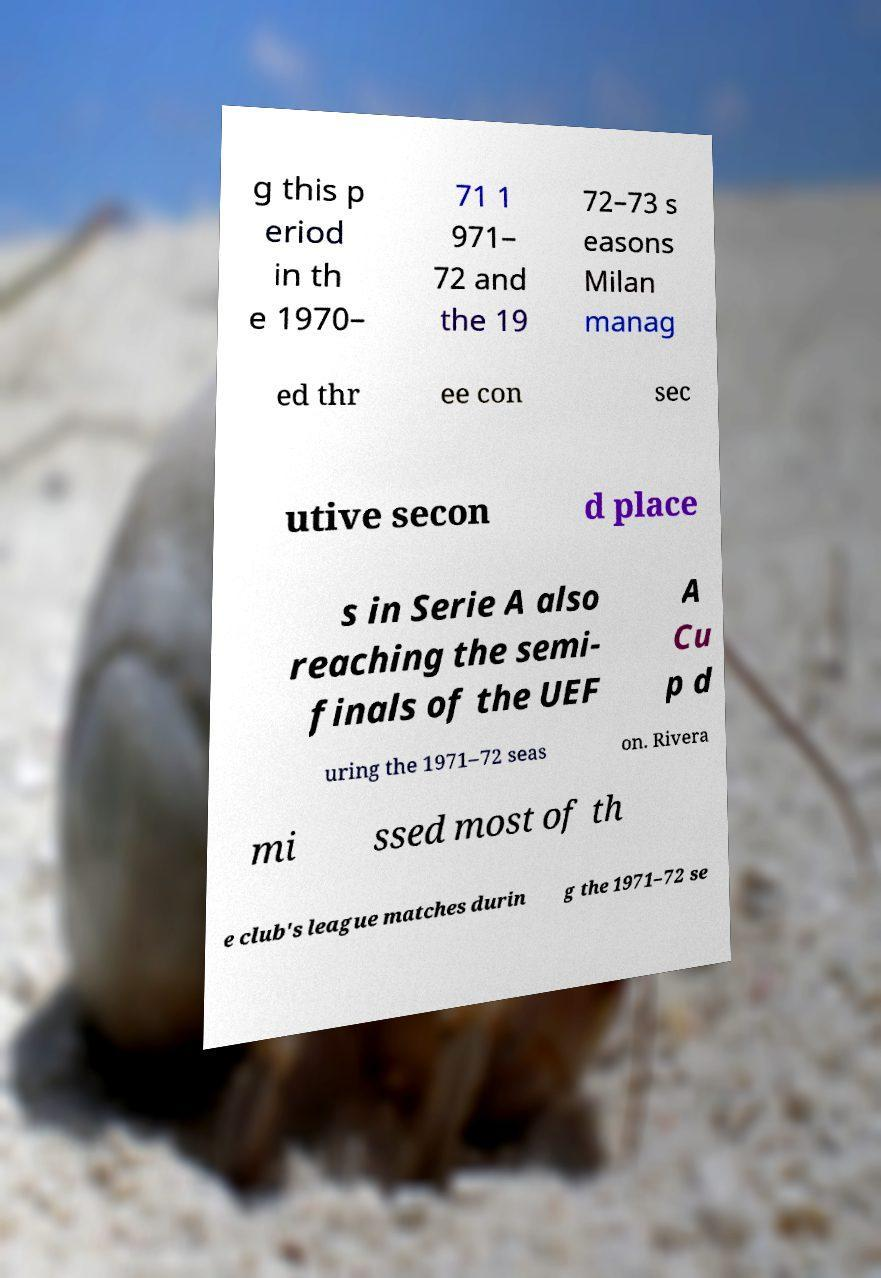Please read and relay the text visible in this image. What does it say? g this p eriod in th e 1970– 71 1 971– 72 and the 19 72–73 s easons Milan manag ed thr ee con sec utive secon d place s in Serie A also reaching the semi- finals of the UEF A Cu p d uring the 1971–72 seas on. Rivera mi ssed most of th e club's league matches durin g the 1971–72 se 